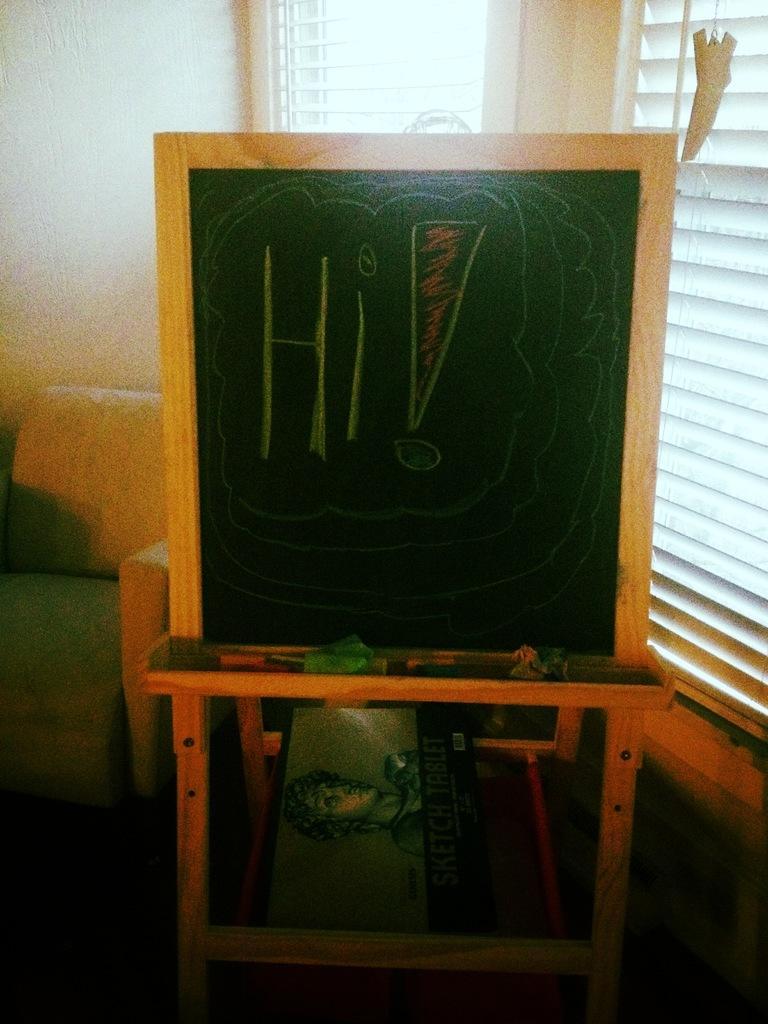Can you describe this image briefly? There is a board on a table in the middle of this image. There is a window in the background. There is a sofa on the left side of this image , and there is a wall at the top of left side of this image. 